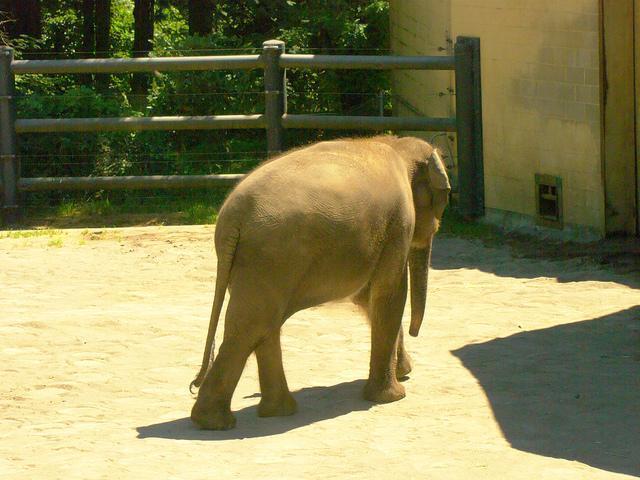How many horizontal bars?
Give a very brief answer. 3. How many elephants are there?
Give a very brief answer. 1. 